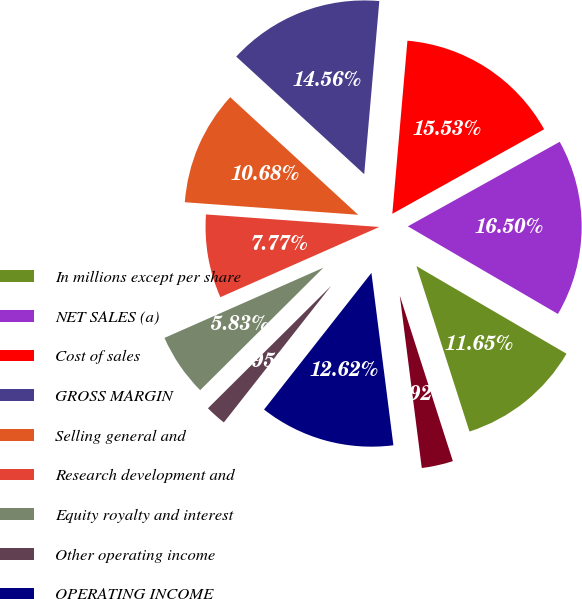<chart> <loc_0><loc_0><loc_500><loc_500><pie_chart><fcel>In millions except per share<fcel>NET SALES (a)<fcel>Cost of sales<fcel>GROSS MARGIN<fcel>Selling general and<fcel>Research development and<fcel>Equity royalty and interest<fcel>Other operating income<fcel>OPERATING INCOME<fcel>Interest income<nl><fcel>11.65%<fcel>16.5%<fcel>15.53%<fcel>14.56%<fcel>10.68%<fcel>7.77%<fcel>5.83%<fcel>1.95%<fcel>12.62%<fcel>2.92%<nl></chart> 